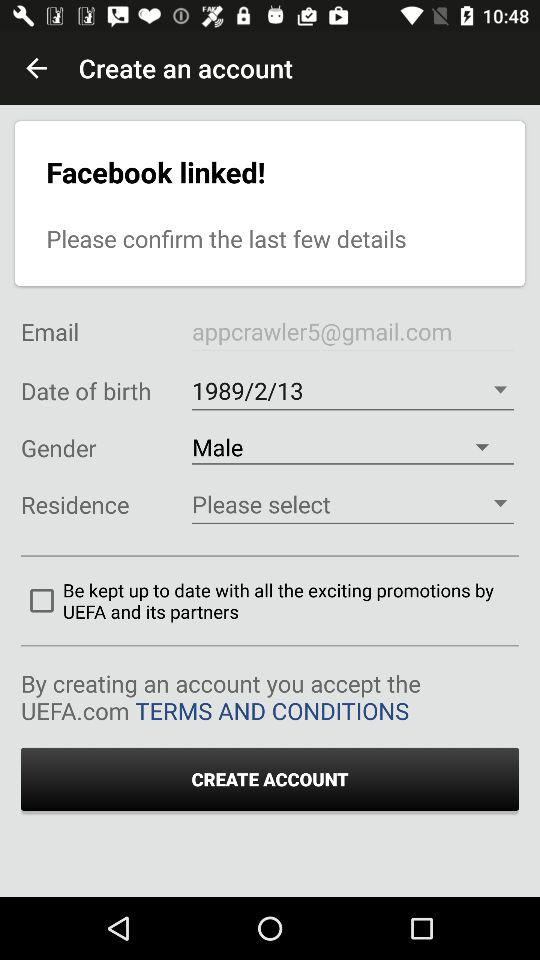What is the date of birth? The date of birth is February 13, 1989. 